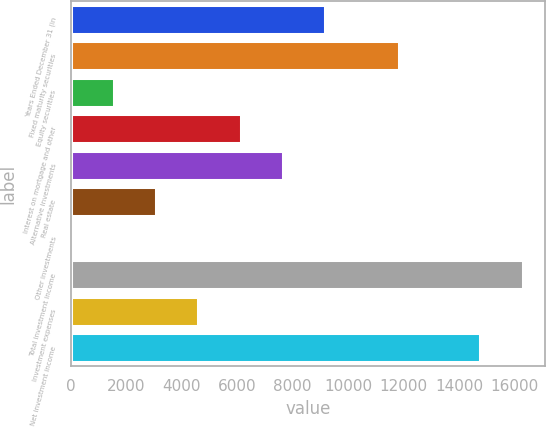Convert chart. <chart><loc_0><loc_0><loc_500><loc_500><bar_chart><fcel>Years Ended December 31 (in<fcel>Fixed maturity securities<fcel>Equity securities<fcel>Interest on mortgage and other<fcel>Alternative investments<fcel>Real estate<fcel>Other investments<fcel>Total investment income<fcel>Investment expenses<fcel>Net investment income<nl><fcel>9172.8<fcel>11814<fcel>1558.8<fcel>6127.2<fcel>7650<fcel>3081.6<fcel>36<fcel>16277.8<fcel>4604.4<fcel>14755<nl></chart> 